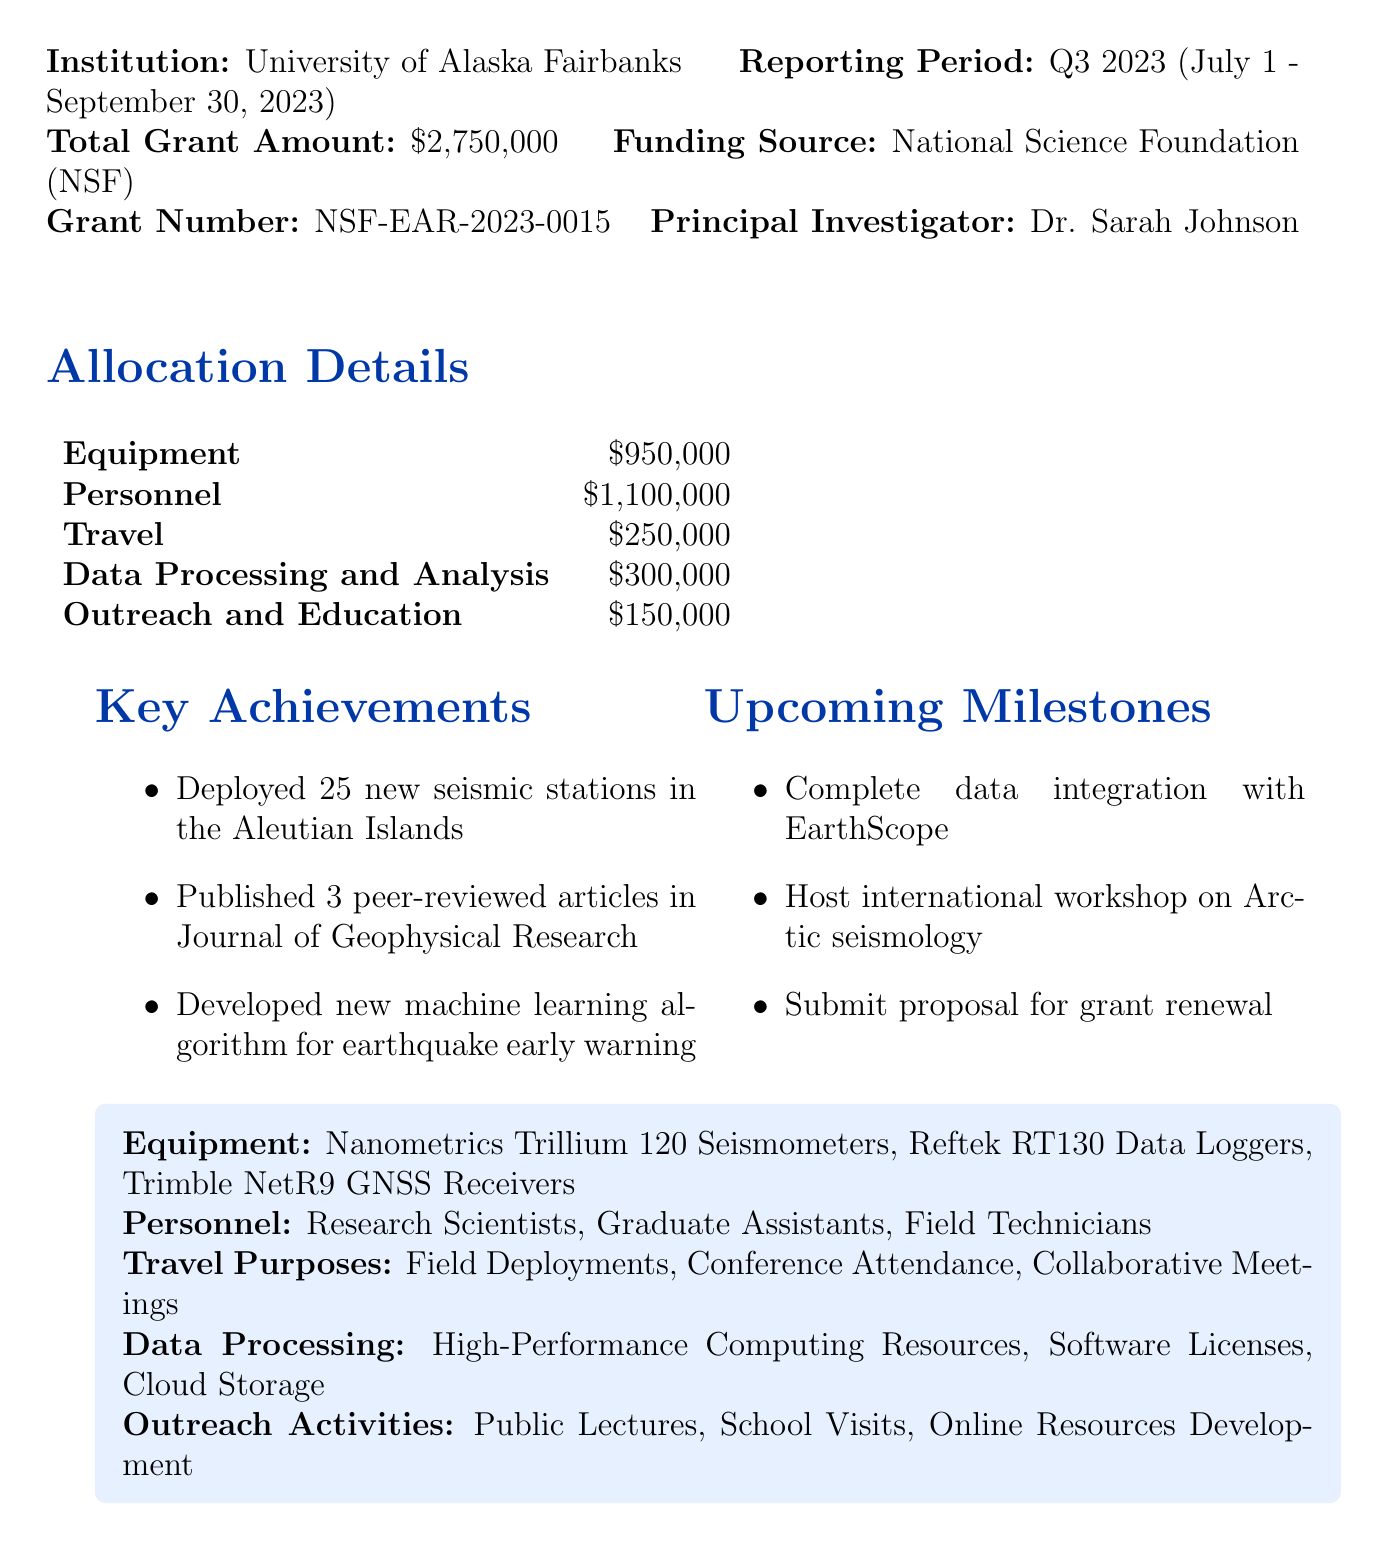What is the total grant amount? The total grant amount is stated clearly in the report as the amount allocated for the project.
Answer: $2,750,000 Who is the principal investigator? The principal investigator is the individual responsible for leading the research project, mentioned in the report.
Answer: Dr. Sarah Johnson What is the funding source? The funding source is an essential detail that identifies the organization providing the grant.
Answer: National Science Foundation (NSF) How much money is allocated for personnel? The amount allocated for personnel is provided in the allocation details section of the report.
Answer: $1,100,000 What was one of the key achievements? A key achievement reflects a significant milestone reached during the reporting period as outlined in the report.
Answer: Deployed 25 new seismic stations in the Aleutian Islands What is one upcoming milestone? An upcoming milestone indicates a future goal the project team aims to achieve, as described in the report.
Answer: Complete data integration with EarthScope What category has the highest funding allocation? This identifies which funding category received the most financial support according to the allocation details in the document.
Answer: Personnel What was the total amount allocated for outreach and education? This amount is specifically stated in the allocation details, highlighting investment in public engagement activities.
Answer: $150,000 What items are listed under equipment? This asks for specific items purchased or funded under the equipment category in the report.
Answer: Nanometrics Trillium 120 Seismometers, Reftek RT130 Data Loggers, Trimble NetR9 GNSS Receivers 